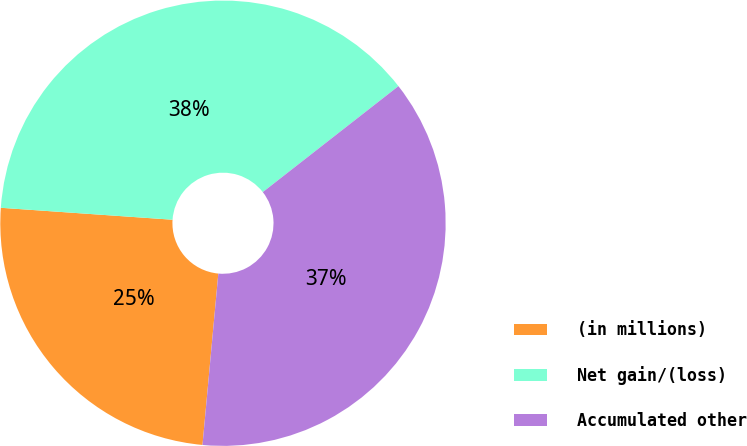<chart> <loc_0><loc_0><loc_500><loc_500><pie_chart><fcel>(in millions)<fcel>Net gain/(loss)<fcel>Accumulated other<nl><fcel>24.64%<fcel>38.34%<fcel>37.02%<nl></chart> 